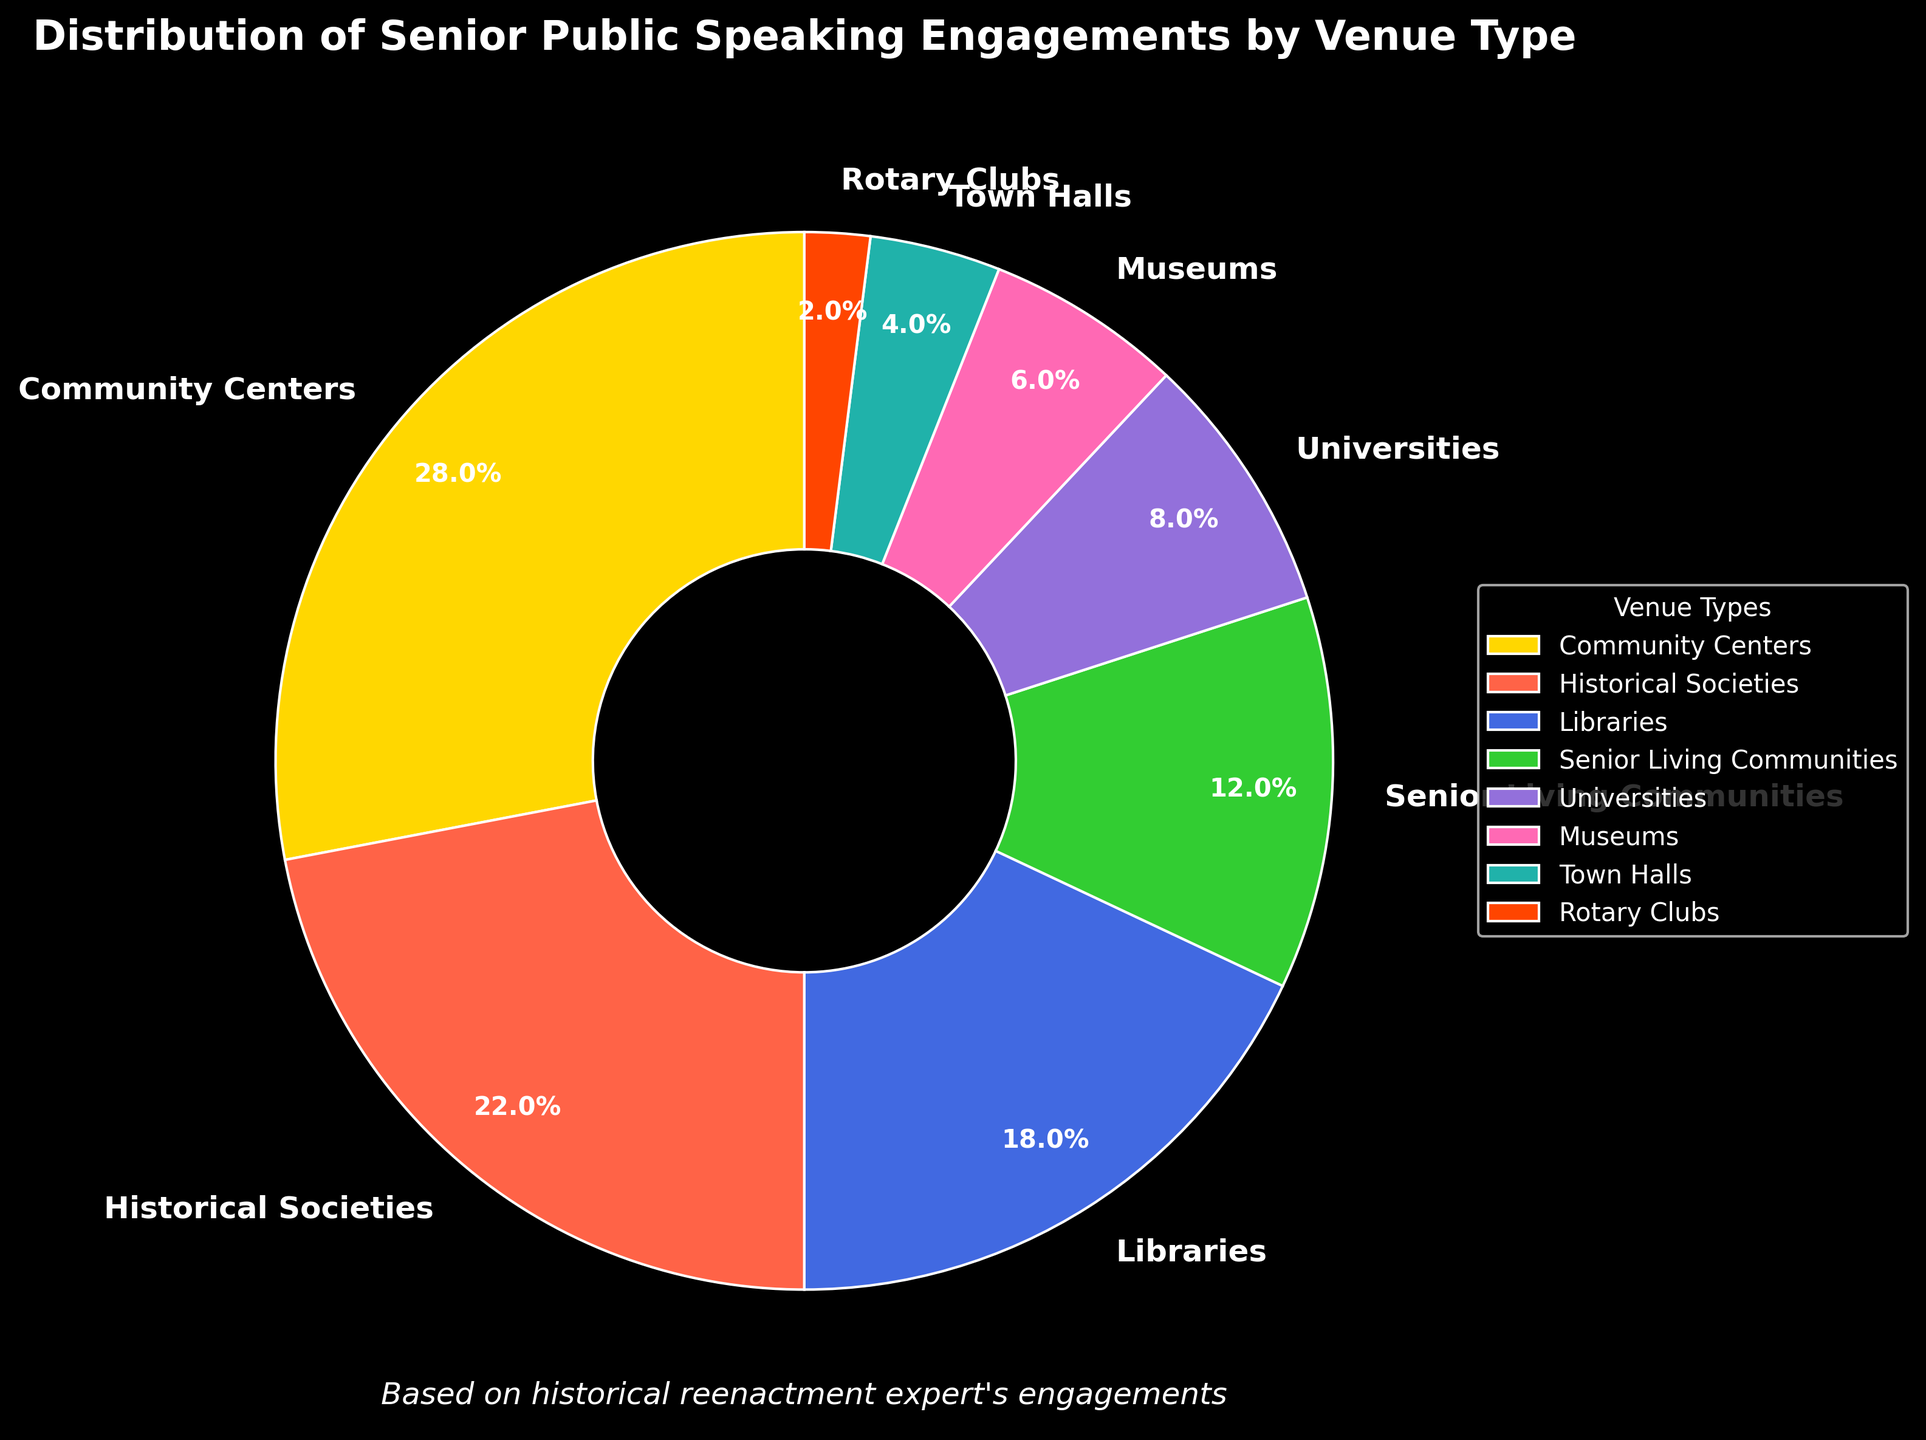Which venue type has the highest percentage of senior public speaking engagements? Look at the chart and identify the segment with the largest portion, which is Community Centers with 28%.
Answer: Community Centers How much larger is the percentage of engagements at Historical Societies compared to Rotary Clubs? Subtract the smaller percentage (Rotary Clubs, 2%) from the larger percentage (Historical Societies, 22%): 22% - 2% = 20%.
Answer: 20% What is the combined percentage of senior public speaking engagements at Libraries and Museums? Add the percentages for Libraries and Museums: 18% + 6% = 24%.
Answer: 24% Which venues account for less than 10% each of senior public speaking engagements? Identify the entries with percentages below 10%: Universities, Museums, Town Halls, and Rotary Clubs.
Answer: Universities, Museums, Town Halls, Rotary Clubs What is the difference in the percentage of engagements between the venue type with the third and fourth highest percentages? The third highest is Libraries (18%) and the fourth is Senior Living Communities (12%). Subtract the two values: 18% - 12% = 6%.
Answer: 6% Which venue type has a larger percentage: Senior Living Communities or Universities? Compare the percentages of Senior Living Communities (12%) and Universities (8%). 12% is larger than 8%.
Answer: Senior Living Communities What is the total percentage of senior public speaking engagements held at venues that are not community centers, historical societies, or libraries? Subtract the sum of the three top venues from 100%: 100% - (28% + 22% + 18%) = 32%.
Answer: 32% Among the listed venue types, which two venues combined have a percentage closest to 30%? Inspect pairs of percentages: Libraries (18%) + Senior Living Communities (12%) = 30%. This pair is exactly 30%.
Answer: Libraries and Senior Living Communities Is the percentage of public speaking engagements at Town Halls more or less than half of that at Historical Societies? Half the percentage of Historical Societies is 22% / 2 = 11%. Town Halls have 4%, which is less than 11%.
Answer: Less What is the smallest percentage of senior public speaking engagements allocated to any venue type? Find the venue with the smallest portion, which is Rotary Clubs at 2%.
Answer: 2% 